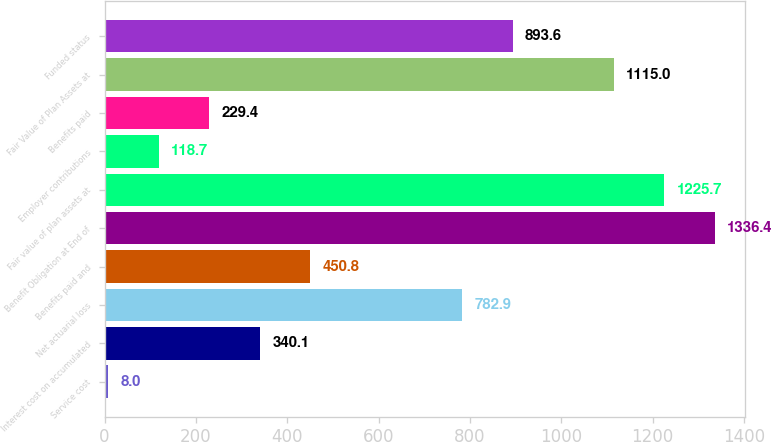<chart> <loc_0><loc_0><loc_500><loc_500><bar_chart><fcel>Service cost<fcel>Interest cost on accumulated<fcel>Net actuarial loss<fcel>Benefits paid and<fcel>Benefit Obligation at End of<fcel>Fair value of plan assets at<fcel>Employer contributions<fcel>Benefits paid<fcel>Fair Value of Plan Assets at<fcel>Funded status<nl><fcel>8<fcel>340.1<fcel>782.9<fcel>450.8<fcel>1336.4<fcel>1225.7<fcel>118.7<fcel>229.4<fcel>1115<fcel>893.6<nl></chart> 